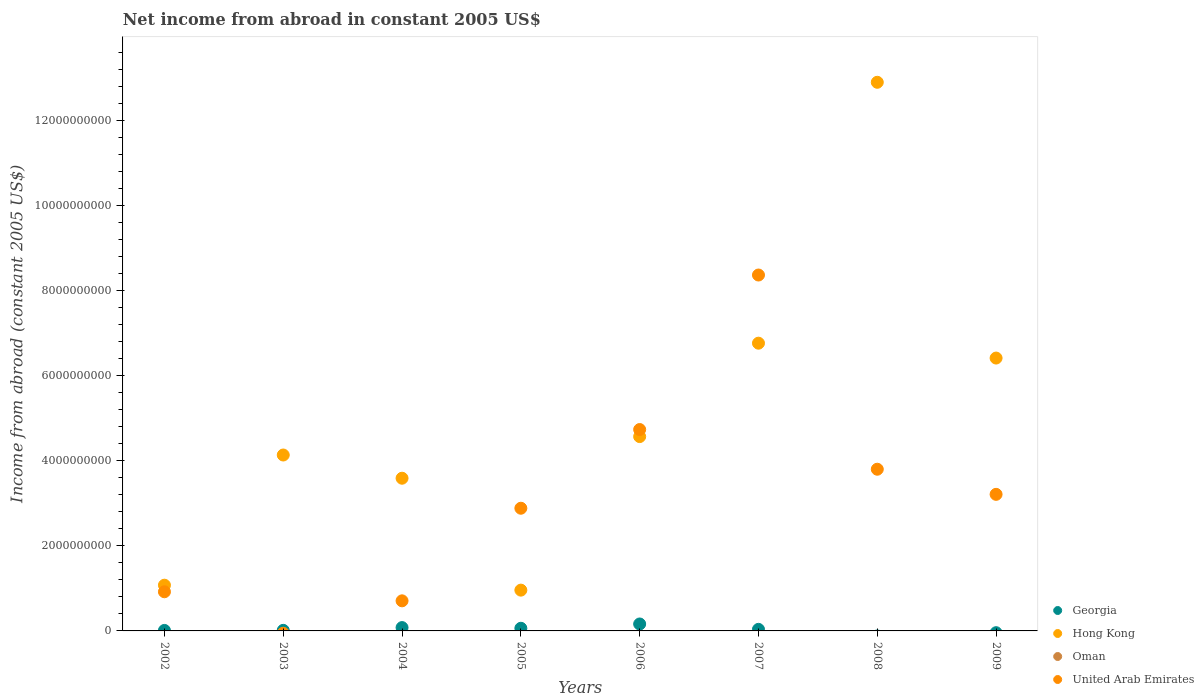Is the number of dotlines equal to the number of legend labels?
Provide a short and direct response. No. Across all years, what is the maximum net income from abroad in Hong Kong?
Provide a succinct answer. 1.29e+1. Across all years, what is the minimum net income from abroad in United Arab Emirates?
Keep it short and to the point. 0. What is the total net income from abroad in Hong Kong in the graph?
Your answer should be compact. 4.04e+1. What is the difference between the net income from abroad in United Arab Emirates in 2004 and that in 2009?
Your answer should be compact. -2.51e+09. What is the difference between the net income from abroad in Georgia in 2005 and the net income from abroad in Oman in 2009?
Offer a very short reply. 6.21e+07. What is the average net income from abroad in United Arab Emirates per year?
Offer a very short reply. 3.08e+09. What is the ratio of the net income from abroad in United Arab Emirates in 2008 to that in 2009?
Your answer should be compact. 1.18. What is the difference between the highest and the second highest net income from abroad in United Arab Emirates?
Your answer should be very brief. 3.64e+09. What is the difference between the highest and the lowest net income from abroad in United Arab Emirates?
Your answer should be compact. 8.37e+09. In how many years, is the net income from abroad in Georgia greater than the average net income from abroad in Georgia taken over all years?
Offer a very short reply. 3. Is the sum of the net income from abroad in United Arab Emirates in 2002 and 2007 greater than the maximum net income from abroad in Hong Kong across all years?
Give a very brief answer. No. Is it the case that in every year, the sum of the net income from abroad in United Arab Emirates and net income from abroad in Georgia  is greater than the sum of net income from abroad in Hong Kong and net income from abroad in Oman?
Your answer should be very brief. No. Is the net income from abroad in Oman strictly greater than the net income from abroad in Georgia over the years?
Make the answer very short. No. Is the net income from abroad in United Arab Emirates strictly less than the net income from abroad in Georgia over the years?
Make the answer very short. No. How many years are there in the graph?
Offer a very short reply. 8. What is the difference between two consecutive major ticks on the Y-axis?
Offer a terse response. 2.00e+09. Does the graph contain any zero values?
Provide a short and direct response. Yes. What is the title of the graph?
Your response must be concise. Net income from abroad in constant 2005 US$. Does "Djibouti" appear as one of the legend labels in the graph?
Offer a terse response. No. What is the label or title of the X-axis?
Your response must be concise. Years. What is the label or title of the Y-axis?
Provide a short and direct response. Income from abroad (constant 2005 US$). What is the Income from abroad (constant 2005 US$) of Georgia in 2002?
Provide a succinct answer. 1.16e+07. What is the Income from abroad (constant 2005 US$) in Hong Kong in 2002?
Provide a succinct answer. 1.08e+09. What is the Income from abroad (constant 2005 US$) in United Arab Emirates in 2002?
Give a very brief answer. 9.21e+08. What is the Income from abroad (constant 2005 US$) of Georgia in 2003?
Provide a succinct answer. 1.35e+07. What is the Income from abroad (constant 2005 US$) in Hong Kong in 2003?
Offer a very short reply. 4.14e+09. What is the Income from abroad (constant 2005 US$) in Oman in 2003?
Your response must be concise. 0. What is the Income from abroad (constant 2005 US$) in Georgia in 2004?
Give a very brief answer. 7.85e+07. What is the Income from abroad (constant 2005 US$) in Hong Kong in 2004?
Ensure brevity in your answer.  3.59e+09. What is the Income from abroad (constant 2005 US$) of Oman in 2004?
Keep it short and to the point. 0. What is the Income from abroad (constant 2005 US$) of United Arab Emirates in 2004?
Your response must be concise. 7.08e+08. What is the Income from abroad (constant 2005 US$) in Georgia in 2005?
Offer a terse response. 6.21e+07. What is the Income from abroad (constant 2005 US$) of Hong Kong in 2005?
Ensure brevity in your answer.  9.60e+08. What is the Income from abroad (constant 2005 US$) of United Arab Emirates in 2005?
Keep it short and to the point. 2.89e+09. What is the Income from abroad (constant 2005 US$) of Georgia in 2006?
Give a very brief answer. 1.63e+08. What is the Income from abroad (constant 2005 US$) in Hong Kong in 2006?
Provide a short and direct response. 4.57e+09. What is the Income from abroad (constant 2005 US$) in United Arab Emirates in 2006?
Provide a succinct answer. 4.74e+09. What is the Income from abroad (constant 2005 US$) of Georgia in 2007?
Give a very brief answer. 3.70e+07. What is the Income from abroad (constant 2005 US$) of Hong Kong in 2007?
Your response must be concise. 6.77e+09. What is the Income from abroad (constant 2005 US$) in United Arab Emirates in 2007?
Offer a very short reply. 8.37e+09. What is the Income from abroad (constant 2005 US$) in Hong Kong in 2008?
Give a very brief answer. 1.29e+1. What is the Income from abroad (constant 2005 US$) in Oman in 2008?
Offer a very short reply. 0. What is the Income from abroad (constant 2005 US$) in United Arab Emirates in 2008?
Provide a succinct answer. 3.80e+09. What is the Income from abroad (constant 2005 US$) of Hong Kong in 2009?
Your answer should be very brief. 6.42e+09. What is the Income from abroad (constant 2005 US$) of Oman in 2009?
Make the answer very short. 0. What is the Income from abroad (constant 2005 US$) in United Arab Emirates in 2009?
Offer a terse response. 3.21e+09. Across all years, what is the maximum Income from abroad (constant 2005 US$) of Georgia?
Your answer should be compact. 1.63e+08. Across all years, what is the maximum Income from abroad (constant 2005 US$) of Hong Kong?
Provide a short and direct response. 1.29e+1. Across all years, what is the maximum Income from abroad (constant 2005 US$) of United Arab Emirates?
Make the answer very short. 8.37e+09. Across all years, what is the minimum Income from abroad (constant 2005 US$) of Hong Kong?
Your response must be concise. 9.60e+08. What is the total Income from abroad (constant 2005 US$) of Georgia in the graph?
Ensure brevity in your answer.  3.66e+08. What is the total Income from abroad (constant 2005 US$) of Hong Kong in the graph?
Your answer should be very brief. 4.04e+1. What is the total Income from abroad (constant 2005 US$) in Oman in the graph?
Provide a succinct answer. 0. What is the total Income from abroad (constant 2005 US$) of United Arab Emirates in the graph?
Keep it short and to the point. 2.46e+1. What is the difference between the Income from abroad (constant 2005 US$) in Georgia in 2002 and that in 2003?
Make the answer very short. -1.88e+06. What is the difference between the Income from abroad (constant 2005 US$) in Hong Kong in 2002 and that in 2003?
Give a very brief answer. -3.06e+09. What is the difference between the Income from abroad (constant 2005 US$) in Georgia in 2002 and that in 2004?
Offer a very short reply. -6.69e+07. What is the difference between the Income from abroad (constant 2005 US$) of Hong Kong in 2002 and that in 2004?
Provide a succinct answer. -2.52e+09. What is the difference between the Income from abroad (constant 2005 US$) of United Arab Emirates in 2002 and that in 2004?
Offer a very short reply. 2.13e+08. What is the difference between the Income from abroad (constant 2005 US$) in Georgia in 2002 and that in 2005?
Your answer should be very brief. -5.06e+07. What is the difference between the Income from abroad (constant 2005 US$) of Hong Kong in 2002 and that in 2005?
Keep it short and to the point. 1.16e+08. What is the difference between the Income from abroad (constant 2005 US$) in United Arab Emirates in 2002 and that in 2005?
Offer a very short reply. -1.97e+09. What is the difference between the Income from abroad (constant 2005 US$) in Georgia in 2002 and that in 2006?
Give a very brief answer. -1.52e+08. What is the difference between the Income from abroad (constant 2005 US$) of Hong Kong in 2002 and that in 2006?
Offer a terse response. -3.50e+09. What is the difference between the Income from abroad (constant 2005 US$) of United Arab Emirates in 2002 and that in 2006?
Provide a succinct answer. -3.82e+09. What is the difference between the Income from abroad (constant 2005 US$) of Georgia in 2002 and that in 2007?
Offer a very short reply. -2.54e+07. What is the difference between the Income from abroad (constant 2005 US$) of Hong Kong in 2002 and that in 2007?
Your response must be concise. -5.69e+09. What is the difference between the Income from abroad (constant 2005 US$) in United Arab Emirates in 2002 and that in 2007?
Provide a succinct answer. -7.45e+09. What is the difference between the Income from abroad (constant 2005 US$) of Hong Kong in 2002 and that in 2008?
Your answer should be compact. -1.18e+1. What is the difference between the Income from abroad (constant 2005 US$) in United Arab Emirates in 2002 and that in 2008?
Your answer should be compact. -2.88e+09. What is the difference between the Income from abroad (constant 2005 US$) of Hong Kong in 2002 and that in 2009?
Your response must be concise. -5.34e+09. What is the difference between the Income from abroad (constant 2005 US$) in United Arab Emirates in 2002 and that in 2009?
Your answer should be very brief. -2.29e+09. What is the difference between the Income from abroad (constant 2005 US$) of Georgia in 2003 and that in 2004?
Keep it short and to the point. -6.50e+07. What is the difference between the Income from abroad (constant 2005 US$) of Hong Kong in 2003 and that in 2004?
Keep it short and to the point. 5.46e+08. What is the difference between the Income from abroad (constant 2005 US$) of Georgia in 2003 and that in 2005?
Provide a short and direct response. -4.87e+07. What is the difference between the Income from abroad (constant 2005 US$) of Hong Kong in 2003 and that in 2005?
Provide a succinct answer. 3.18e+09. What is the difference between the Income from abroad (constant 2005 US$) in Georgia in 2003 and that in 2006?
Make the answer very short. -1.50e+08. What is the difference between the Income from abroad (constant 2005 US$) in Hong Kong in 2003 and that in 2006?
Provide a succinct answer. -4.33e+08. What is the difference between the Income from abroad (constant 2005 US$) in Georgia in 2003 and that in 2007?
Provide a short and direct response. -2.35e+07. What is the difference between the Income from abroad (constant 2005 US$) of Hong Kong in 2003 and that in 2007?
Offer a very short reply. -2.63e+09. What is the difference between the Income from abroad (constant 2005 US$) of Hong Kong in 2003 and that in 2008?
Offer a very short reply. -8.77e+09. What is the difference between the Income from abroad (constant 2005 US$) in Hong Kong in 2003 and that in 2009?
Your answer should be very brief. -2.28e+09. What is the difference between the Income from abroad (constant 2005 US$) of Georgia in 2004 and that in 2005?
Your answer should be compact. 1.63e+07. What is the difference between the Income from abroad (constant 2005 US$) in Hong Kong in 2004 and that in 2005?
Offer a very short reply. 2.63e+09. What is the difference between the Income from abroad (constant 2005 US$) of United Arab Emirates in 2004 and that in 2005?
Give a very brief answer. -2.18e+09. What is the difference between the Income from abroad (constant 2005 US$) in Georgia in 2004 and that in 2006?
Your response must be concise. -8.48e+07. What is the difference between the Income from abroad (constant 2005 US$) in Hong Kong in 2004 and that in 2006?
Your answer should be compact. -9.80e+08. What is the difference between the Income from abroad (constant 2005 US$) of United Arab Emirates in 2004 and that in 2006?
Give a very brief answer. -4.03e+09. What is the difference between the Income from abroad (constant 2005 US$) in Georgia in 2004 and that in 2007?
Ensure brevity in your answer.  4.15e+07. What is the difference between the Income from abroad (constant 2005 US$) in Hong Kong in 2004 and that in 2007?
Your answer should be compact. -3.18e+09. What is the difference between the Income from abroad (constant 2005 US$) in United Arab Emirates in 2004 and that in 2007?
Offer a very short reply. -7.67e+09. What is the difference between the Income from abroad (constant 2005 US$) in Hong Kong in 2004 and that in 2008?
Provide a succinct answer. -9.31e+09. What is the difference between the Income from abroad (constant 2005 US$) in United Arab Emirates in 2004 and that in 2008?
Give a very brief answer. -3.10e+09. What is the difference between the Income from abroad (constant 2005 US$) in Hong Kong in 2004 and that in 2009?
Offer a very short reply. -2.83e+09. What is the difference between the Income from abroad (constant 2005 US$) in United Arab Emirates in 2004 and that in 2009?
Ensure brevity in your answer.  -2.51e+09. What is the difference between the Income from abroad (constant 2005 US$) in Georgia in 2005 and that in 2006?
Offer a very short reply. -1.01e+08. What is the difference between the Income from abroad (constant 2005 US$) in Hong Kong in 2005 and that in 2006?
Give a very brief answer. -3.61e+09. What is the difference between the Income from abroad (constant 2005 US$) in United Arab Emirates in 2005 and that in 2006?
Your response must be concise. -1.85e+09. What is the difference between the Income from abroad (constant 2005 US$) in Georgia in 2005 and that in 2007?
Offer a terse response. 2.52e+07. What is the difference between the Income from abroad (constant 2005 US$) of Hong Kong in 2005 and that in 2007?
Offer a very short reply. -5.81e+09. What is the difference between the Income from abroad (constant 2005 US$) in United Arab Emirates in 2005 and that in 2007?
Offer a terse response. -5.49e+09. What is the difference between the Income from abroad (constant 2005 US$) in Hong Kong in 2005 and that in 2008?
Ensure brevity in your answer.  -1.19e+1. What is the difference between the Income from abroad (constant 2005 US$) of United Arab Emirates in 2005 and that in 2008?
Your answer should be very brief. -9.18e+08. What is the difference between the Income from abroad (constant 2005 US$) of Hong Kong in 2005 and that in 2009?
Provide a short and direct response. -5.46e+09. What is the difference between the Income from abroad (constant 2005 US$) in United Arab Emirates in 2005 and that in 2009?
Your answer should be compact. -3.27e+08. What is the difference between the Income from abroad (constant 2005 US$) in Georgia in 2006 and that in 2007?
Keep it short and to the point. 1.26e+08. What is the difference between the Income from abroad (constant 2005 US$) in Hong Kong in 2006 and that in 2007?
Your response must be concise. -2.20e+09. What is the difference between the Income from abroad (constant 2005 US$) in United Arab Emirates in 2006 and that in 2007?
Provide a short and direct response. -3.64e+09. What is the difference between the Income from abroad (constant 2005 US$) of Hong Kong in 2006 and that in 2008?
Make the answer very short. -8.34e+09. What is the difference between the Income from abroad (constant 2005 US$) in United Arab Emirates in 2006 and that in 2008?
Make the answer very short. 9.34e+08. What is the difference between the Income from abroad (constant 2005 US$) in Hong Kong in 2006 and that in 2009?
Give a very brief answer. -1.85e+09. What is the difference between the Income from abroad (constant 2005 US$) of United Arab Emirates in 2006 and that in 2009?
Your response must be concise. 1.52e+09. What is the difference between the Income from abroad (constant 2005 US$) of Hong Kong in 2007 and that in 2008?
Offer a terse response. -6.14e+09. What is the difference between the Income from abroad (constant 2005 US$) of United Arab Emirates in 2007 and that in 2008?
Give a very brief answer. 4.57e+09. What is the difference between the Income from abroad (constant 2005 US$) of Hong Kong in 2007 and that in 2009?
Offer a very short reply. 3.50e+08. What is the difference between the Income from abroad (constant 2005 US$) of United Arab Emirates in 2007 and that in 2009?
Provide a succinct answer. 5.16e+09. What is the difference between the Income from abroad (constant 2005 US$) in Hong Kong in 2008 and that in 2009?
Your answer should be very brief. 6.49e+09. What is the difference between the Income from abroad (constant 2005 US$) of United Arab Emirates in 2008 and that in 2009?
Keep it short and to the point. 5.91e+08. What is the difference between the Income from abroad (constant 2005 US$) in Georgia in 2002 and the Income from abroad (constant 2005 US$) in Hong Kong in 2003?
Your answer should be compact. -4.13e+09. What is the difference between the Income from abroad (constant 2005 US$) of Georgia in 2002 and the Income from abroad (constant 2005 US$) of Hong Kong in 2004?
Provide a short and direct response. -3.58e+09. What is the difference between the Income from abroad (constant 2005 US$) in Georgia in 2002 and the Income from abroad (constant 2005 US$) in United Arab Emirates in 2004?
Your answer should be very brief. -6.96e+08. What is the difference between the Income from abroad (constant 2005 US$) of Hong Kong in 2002 and the Income from abroad (constant 2005 US$) of United Arab Emirates in 2004?
Provide a short and direct response. 3.68e+08. What is the difference between the Income from abroad (constant 2005 US$) in Georgia in 2002 and the Income from abroad (constant 2005 US$) in Hong Kong in 2005?
Make the answer very short. -9.48e+08. What is the difference between the Income from abroad (constant 2005 US$) in Georgia in 2002 and the Income from abroad (constant 2005 US$) in United Arab Emirates in 2005?
Ensure brevity in your answer.  -2.87e+09. What is the difference between the Income from abroad (constant 2005 US$) in Hong Kong in 2002 and the Income from abroad (constant 2005 US$) in United Arab Emirates in 2005?
Make the answer very short. -1.81e+09. What is the difference between the Income from abroad (constant 2005 US$) in Georgia in 2002 and the Income from abroad (constant 2005 US$) in Hong Kong in 2006?
Keep it short and to the point. -4.56e+09. What is the difference between the Income from abroad (constant 2005 US$) of Georgia in 2002 and the Income from abroad (constant 2005 US$) of United Arab Emirates in 2006?
Offer a very short reply. -4.73e+09. What is the difference between the Income from abroad (constant 2005 US$) of Hong Kong in 2002 and the Income from abroad (constant 2005 US$) of United Arab Emirates in 2006?
Ensure brevity in your answer.  -3.66e+09. What is the difference between the Income from abroad (constant 2005 US$) in Georgia in 2002 and the Income from abroad (constant 2005 US$) in Hong Kong in 2007?
Provide a short and direct response. -6.76e+09. What is the difference between the Income from abroad (constant 2005 US$) of Georgia in 2002 and the Income from abroad (constant 2005 US$) of United Arab Emirates in 2007?
Keep it short and to the point. -8.36e+09. What is the difference between the Income from abroad (constant 2005 US$) of Hong Kong in 2002 and the Income from abroad (constant 2005 US$) of United Arab Emirates in 2007?
Give a very brief answer. -7.30e+09. What is the difference between the Income from abroad (constant 2005 US$) of Georgia in 2002 and the Income from abroad (constant 2005 US$) of Hong Kong in 2008?
Offer a terse response. -1.29e+1. What is the difference between the Income from abroad (constant 2005 US$) in Georgia in 2002 and the Income from abroad (constant 2005 US$) in United Arab Emirates in 2008?
Your answer should be very brief. -3.79e+09. What is the difference between the Income from abroad (constant 2005 US$) of Hong Kong in 2002 and the Income from abroad (constant 2005 US$) of United Arab Emirates in 2008?
Your answer should be very brief. -2.73e+09. What is the difference between the Income from abroad (constant 2005 US$) of Georgia in 2002 and the Income from abroad (constant 2005 US$) of Hong Kong in 2009?
Ensure brevity in your answer.  -6.41e+09. What is the difference between the Income from abroad (constant 2005 US$) in Georgia in 2002 and the Income from abroad (constant 2005 US$) in United Arab Emirates in 2009?
Make the answer very short. -3.20e+09. What is the difference between the Income from abroad (constant 2005 US$) of Hong Kong in 2002 and the Income from abroad (constant 2005 US$) of United Arab Emirates in 2009?
Your answer should be compact. -2.14e+09. What is the difference between the Income from abroad (constant 2005 US$) in Georgia in 2003 and the Income from abroad (constant 2005 US$) in Hong Kong in 2004?
Provide a short and direct response. -3.58e+09. What is the difference between the Income from abroad (constant 2005 US$) of Georgia in 2003 and the Income from abroad (constant 2005 US$) of United Arab Emirates in 2004?
Provide a short and direct response. -6.94e+08. What is the difference between the Income from abroad (constant 2005 US$) in Hong Kong in 2003 and the Income from abroad (constant 2005 US$) in United Arab Emirates in 2004?
Ensure brevity in your answer.  3.43e+09. What is the difference between the Income from abroad (constant 2005 US$) in Georgia in 2003 and the Income from abroad (constant 2005 US$) in Hong Kong in 2005?
Your response must be concise. -9.46e+08. What is the difference between the Income from abroad (constant 2005 US$) in Georgia in 2003 and the Income from abroad (constant 2005 US$) in United Arab Emirates in 2005?
Your answer should be compact. -2.87e+09. What is the difference between the Income from abroad (constant 2005 US$) in Hong Kong in 2003 and the Income from abroad (constant 2005 US$) in United Arab Emirates in 2005?
Provide a succinct answer. 1.25e+09. What is the difference between the Income from abroad (constant 2005 US$) of Georgia in 2003 and the Income from abroad (constant 2005 US$) of Hong Kong in 2006?
Offer a very short reply. -4.56e+09. What is the difference between the Income from abroad (constant 2005 US$) of Georgia in 2003 and the Income from abroad (constant 2005 US$) of United Arab Emirates in 2006?
Ensure brevity in your answer.  -4.72e+09. What is the difference between the Income from abroad (constant 2005 US$) in Hong Kong in 2003 and the Income from abroad (constant 2005 US$) in United Arab Emirates in 2006?
Provide a short and direct response. -5.99e+08. What is the difference between the Income from abroad (constant 2005 US$) in Georgia in 2003 and the Income from abroad (constant 2005 US$) in Hong Kong in 2007?
Your answer should be very brief. -6.76e+09. What is the difference between the Income from abroad (constant 2005 US$) in Georgia in 2003 and the Income from abroad (constant 2005 US$) in United Arab Emirates in 2007?
Keep it short and to the point. -8.36e+09. What is the difference between the Income from abroad (constant 2005 US$) in Hong Kong in 2003 and the Income from abroad (constant 2005 US$) in United Arab Emirates in 2007?
Your response must be concise. -4.23e+09. What is the difference between the Income from abroad (constant 2005 US$) in Georgia in 2003 and the Income from abroad (constant 2005 US$) in Hong Kong in 2008?
Ensure brevity in your answer.  -1.29e+1. What is the difference between the Income from abroad (constant 2005 US$) of Georgia in 2003 and the Income from abroad (constant 2005 US$) of United Arab Emirates in 2008?
Give a very brief answer. -3.79e+09. What is the difference between the Income from abroad (constant 2005 US$) of Hong Kong in 2003 and the Income from abroad (constant 2005 US$) of United Arab Emirates in 2008?
Offer a terse response. 3.35e+08. What is the difference between the Income from abroad (constant 2005 US$) of Georgia in 2003 and the Income from abroad (constant 2005 US$) of Hong Kong in 2009?
Your answer should be very brief. -6.41e+09. What is the difference between the Income from abroad (constant 2005 US$) in Georgia in 2003 and the Income from abroad (constant 2005 US$) in United Arab Emirates in 2009?
Provide a succinct answer. -3.20e+09. What is the difference between the Income from abroad (constant 2005 US$) of Hong Kong in 2003 and the Income from abroad (constant 2005 US$) of United Arab Emirates in 2009?
Ensure brevity in your answer.  9.25e+08. What is the difference between the Income from abroad (constant 2005 US$) of Georgia in 2004 and the Income from abroad (constant 2005 US$) of Hong Kong in 2005?
Your response must be concise. -8.81e+08. What is the difference between the Income from abroad (constant 2005 US$) of Georgia in 2004 and the Income from abroad (constant 2005 US$) of United Arab Emirates in 2005?
Keep it short and to the point. -2.81e+09. What is the difference between the Income from abroad (constant 2005 US$) in Hong Kong in 2004 and the Income from abroad (constant 2005 US$) in United Arab Emirates in 2005?
Provide a succinct answer. 7.06e+08. What is the difference between the Income from abroad (constant 2005 US$) of Georgia in 2004 and the Income from abroad (constant 2005 US$) of Hong Kong in 2006?
Provide a short and direct response. -4.49e+09. What is the difference between the Income from abroad (constant 2005 US$) in Georgia in 2004 and the Income from abroad (constant 2005 US$) in United Arab Emirates in 2006?
Offer a terse response. -4.66e+09. What is the difference between the Income from abroad (constant 2005 US$) of Hong Kong in 2004 and the Income from abroad (constant 2005 US$) of United Arab Emirates in 2006?
Make the answer very short. -1.15e+09. What is the difference between the Income from abroad (constant 2005 US$) in Georgia in 2004 and the Income from abroad (constant 2005 US$) in Hong Kong in 2007?
Make the answer very short. -6.69e+09. What is the difference between the Income from abroad (constant 2005 US$) of Georgia in 2004 and the Income from abroad (constant 2005 US$) of United Arab Emirates in 2007?
Your answer should be compact. -8.29e+09. What is the difference between the Income from abroad (constant 2005 US$) of Hong Kong in 2004 and the Income from abroad (constant 2005 US$) of United Arab Emirates in 2007?
Your answer should be compact. -4.78e+09. What is the difference between the Income from abroad (constant 2005 US$) of Georgia in 2004 and the Income from abroad (constant 2005 US$) of Hong Kong in 2008?
Offer a very short reply. -1.28e+1. What is the difference between the Income from abroad (constant 2005 US$) of Georgia in 2004 and the Income from abroad (constant 2005 US$) of United Arab Emirates in 2008?
Keep it short and to the point. -3.73e+09. What is the difference between the Income from abroad (constant 2005 US$) of Hong Kong in 2004 and the Income from abroad (constant 2005 US$) of United Arab Emirates in 2008?
Offer a very short reply. -2.11e+08. What is the difference between the Income from abroad (constant 2005 US$) of Georgia in 2004 and the Income from abroad (constant 2005 US$) of Hong Kong in 2009?
Ensure brevity in your answer.  -6.34e+09. What is the difference between the Income from abroad (constant 2005 US$) in Georgia in 2004 and the Income from abroad (constant 2005 US$) in United Arab Emirates in 2009?
Make the answer very short. -3.13e+09. What is the difference between the Income from abroad (constant 2005 US$) in Hong Kong in 2004 and the Income from abroad (constant 2005 US$) in United Arab Emirates in 2009?
Offer a very short reply. 3.79e+08. What is the difference between the Income from abroad (constant 2005 US$) in Georgia in 2005 and the Income from abroad (constant 2005 US$) in Hong Kong in 2006?
Your answer should be compact. -4.51e+09. What is the difference between the Income from abroad (constant 2005 US$) in Georgia in 2005 and the Income from abroad (constant 2005 US$) in United Arab Emirates in 2006?
Offer a very short reply. -4.68e+09. What is the difference between the Income from abroad (constant 2005 US$) in Hong Kong in 2005 and the Income from abroad (constant 2005 US$) in United Arab Emirates in 2006?
Give a very brief answer. -3.78e+09. What is the difference between the Income from abroad (constant 2005 US$) of Georgia in 2005 and the Income from abroad (constant 2005 US$) of Hong Kong in 2007?
Offer a very short reply. -6.71e+09. What is the difference between the Income from abroad (constant 2005 US$) of Georgia in 2005 and the Income from abroad (constant 2005 US$) of United Arab Emirates in 2007?
Your response must be concise. -8.31e+09. What is the difference between the Income from abroad (constant 2005 US$) in Hong Kong in 2005 and the Income from abroad (constant 2005 US$) in United Arab Emirates in 2007?
Keep it short and to the point. -7.41e+09. What is the difference between the Income from abroad (constant 2005 US$) in Georgia in 2005 and the Income from abroad (constant 2005 US$) in Hong Kong in 2008?
Your response must be concise. -1.28e+1. What is the difference between the Income from abroad (constant 2005 US$) of Georgia in 2005 and the Income from abroad (constant 2005 US$) of United Arab Emirates in 2008?
Your response must be concise. -3.74e+09. What is the difference between the Income from abroad (constant 2005 US$) of Hong Kong in 2005 and the Income from abroad (constant 2005 US$) of United Arab Emirates in 2008?
Make the answer very short. -2.84e+09. What is the difference between the Income from abroad (constant 2005 US$) of Georgia in 2005 and the Income from abroad (constant 2005 US$) of Hong Kong in 2009?
Your answer should be compact. -6.36e+09. What is the difference between the Income from abroad (constant 2005 US$) of Georgia in 2005 and the Income from abroad (constant 2005 US$) of United Arab Emirates in 2009?
Make the answer very short. -3.15e+09. What is the difference between the Income from abroad (constant 2005 US$) of Hong Kong in 2005 and the Income from abroad (constant 2005 US$) of United Arab Emirates in 2009?
Keep it short and to the point. -2.25e+09. What is the difference between the Income from abroad (constant 2005 US$) in Georgia in 2006 and the Income from abroad (constant 2005 US$) in Hong Kong in 2007?
Provide a succinct answer. -6.61e+09. What is the difference between the Income from abroad (constant 2005 US$) in Georgia in 2006 and the Income from abroad (constant 2005 US$) in United Arab Emirates in 2007?
Keep it short and to the point. -8.21e+09. What is the difference between the Income from abroad (constant 2005 US$) in Hong Kong in 2006 and the Income from abroad (constant 2005 US$) in United Arab Emirates in 2007?
Your answer should be very brief. -3.80e+09. What is the difference between the Income from abroad (constant 2005 US$) of Georgia in 2006 and the Income from abroad (constant 2005 US$) of Hong Kong in 2008?
Your response must be concise. -1.27e+1. What is the difference between the Income from abroad (constant 2005 US$) in Georgia in 2006 and the Income from abroad (constant 2005 US$) in United Arab Emirates in 2008?
Provide a short and direct response. -3.64e+09. What is the difference between the Income from abroad (constant 2005 US$) in Hong Kong in 2006 and the Income from abroad (constant 2005 US$) in United Arab Emirates in 2008?
Provide a short and direct response. 7.68e+08. What is the difference between the Income from abroad (constant 2005 US$) in Georgia in 2006 and the Income from abroad (constant 2005 US$) in Hong Kong in 2009?
Your answer should be very brief. -6.26e+09. What is the difference between the Income from abroad (constant 2005 US$) in Georgia in 2006 and the Income from abroad (constant 2005 US$) in United Arab Emirates in 2009?
Offer a terse response. -3.05e+09. What is the difference between the Income from abroad (constant 2005 US$) of Hong Kong in 2006 and the Income from abroad (constant 2005 US$) of United Arab Emirates in 2009?
Your answer should be very brief. 1.36e+09. What is the difference between the Income from abroad (constant 2005 US$) of Georgia in 2007 and the Income from abroad (constant 2005 US$) of Hong Kong in 2008?
Provide a succinct answer. -1.29e+1. What is the difference between the Income from abroad (constant 2005 US$) of Georgia in 2007 and the Income from abroad (constant 2005 US$) of United Arab Emirates in 2008?
Your response must be concise. -3.77e+09. What is the difference between the Income from abroad (constant 2005 US$) in Hong Kong in 2007 and the Income from abroad (constant 2005 US$) in United Arab Emirates in 2008?
Provide a succinct answer. 2.97e+09. What is the difference between the Income from abroad (constant 2005 US$) in Georgia in 2007 and the Income from abroad (constant 2005 US$) in Hong Kong in 2009?
Give a very brief answer. -6.38e+09. What is the difference between the Income from abroad (constant 2005 US$) in Georgia in 2007 and the Income from abroad (constant 2005 US$) in United Arab Emirates in 2009?
Your answer should be very brief. -3.18e+09. What is the difference between the Income from abroad (constant 2005 US$) in Hong Kong in 2007 and the Income from abroad (constant 2005 US$) in United Arab Emirates in 2009?
Your answer should be compact. 3.56e+09. What is the difference between the Income from abroad (constant 2005 US$) in Hong Kong in 2008 and the Income from abroad (constant 2005 US$) in United Arab Emirates in 2009?
Offer a terse response. 9.69e+09. What is the average Income from abroad (constant 2005 US$) in Georgia per year?
Your response must be concise. 4.57e+07. What is the average Income from abroad (constant 2005 US$) in Hong Kong per year?
Make the answer very short. 5.05e+09. What is the average Income from abroad (constant 2005 US$) in United Arab Emirates per year?
Provide a succinct answer. 3.08e+09. In the year 2002, what is the difference between the Income from abroad (constant 2005 US$) of Georgia and Income from abroad (constant 2005 US$) of Hong Kong?
Give a very brief answer. -1.06e+09. In the year 2002, what is the difference between the Income from abroad (constant 2005 US$) of Georgia and Income from abroad (constant 2005 US$) of United Arab Emirates?
Provide a short and direct response. -9.10e+08. In the year 2002, what is the difference between the Income from abroad (constant 2005 US$) of Hong Kong and Income from abroad (constant 2005 US$) of United Arab Emirates?
Your answer should be very brief. 1.55e+08. In the year 2003, what is the difference between the Income from abroad (constant 2005 US$) in Georgia and Income from abroad (constant 2005 US$) in Hong Kong?
Your answer should be very brief. -4.13e+09. In the year 2004, what is the difference between the Income from abroad (constant 2005 US$) in Georgia and Income from abroad (constant 2005 US$) in Hong Kong?
Offer a very short reply. -3.51e+09. In the year 2004, what is the difference between the Income from abroad (constant 2005 US$) of Georgia and Income from abroad (constant 2005 US$) of United Arab Emirates?
Your answer should be very brief. -6.29e+08. In the year 2004, what is the difference between the Income from abroad (constant 2005 US$) in Hong Kong and Income from abroad (constant 2005 US$) in United Arab Emirates?
Provide a succinct answer. 2.88e+09. In the year 2005, what is the difference between the Income from abroad (constant 2005 US$) in Georgia and Income from abroad (constant 2005 US$) in Hong Kong?
Your response must be concise. -8.97e+08. In the year 2005, what is the difference between the Income from abroad (constant 2005 US$) in Georgia and Income from abroad (constant 2005 US$) in United Arab Emirates?
Offer a very short reply. -2.82e+09. In the year 2005, what is the difference between the Income from abroad (constant 2005 US$) in Hong Kong and Income from abroad (constant 2005 US$) in United Arab Emirates?
Keep it short and to the point. -1.93e+09. In the year 2006, what is the difference between the Income from abroad (constant 2005 US$) in Georgia and Income from abroad (constant 2005 US$) in Hong Kong?
Offer a terse response. -4.41e+09. In the year 2006, what is the difference between the Income from abroad (constant 2005 US$) of Georgia and Income from abroad (constant 2005 US$) of United Arab Emirates?
Make the answer very short. -4.57e+09. In the year 2006, what is the difference between the Income from abroad (constant 2005 US$) of Hong Kong and Income from abroad (constant 2005 US$) of United Arab Emirates?
Offer a terse response. -1.66e+08. In the year 2007, what is the difference between the Income from abroad (constant 2005 US$) of Georgia and Income from abroad (constant 2005 US$) of Hong Kong?
Make the answer very short. -6.73e+09. In the year 2007, what is the difference between the Income from abroad (constant 2005 US$) in Georgia and Income from abroad (constant 2005 US$) in United Arab Emirates?
Your answer should be compact. -8.34e+09. In the year 2007, what is the difference between the Income from abroad (constant 2005 US$) of Hong Kong and Income from abroad (constant 2005 US$) of United Arab Emirates?
Offer a very short reply. -1.60e+09. In the year 2008, what is the difference between the Income from abroad (constant 2005 US$) in Hong Kong and Income from abroad (constant 2005 US$) in United Arab Emirates?
Provide a succinct answer. 9.10e+09. In the year 2009, what is the difference between the Income from abroad (constant 2005 US$) in Hong Kong and Income from abroad (constant 2005 US$) in United Arab Emirates?
Keep it short and to the point. 3.21e+09. What is the ratio of the Income from abroad (constant 2005 US$) of Georgia in 2002 to that in 2003?
Ensure brevity in your answer.  0.86. What is the ratio of the Income from abroad (constant 2005 US$) in Hong Kong in 2002 to that in 2003?
Ensure brevity in your answer.  0.26. What is the ratio of the Income from abroad (constant 2005 US$) in Georgia in 2002 to that in 2004?
Give a very brief answer. 0.15. What is the ratio of the Income from abroad (constant 2005 US$) in Hong Kong in 2002 to that in 2004?
Give a very brief answer. 0.3. What is the ratio of the Income from abroad (constant 2005 US$) in United Arab Emirates in 2002 to that in 2004?
Offer a terse response. 1.3. What is the ratio of the Income from abroad (constant 2005 US$) of Georgia in 2002 to that in 2005?
Keep it short and to the point. 0.19. What is the ratio of the Income from abroad (constant 2005 US$) of Hong Kong in 2002 to that in 2005?
Keep it short and to the point. 1.12. What is the ratio of the Income from abroad (constant 2005 US$) of United Arab Emirates in 2002 to that in 2005?
Give a very brief answer. 0.32. What is the ratio of the Income from abroad (constant 2005 US$) in Georgia in 2002 to that in 2006?
Provide a succinct answer. 0.07. What is the ratio of the Income from abroad (constant 2005 US$) in Hong Kong in 2002 to that in 2006?
Offer a very short reply. 0.24. What is the ratio of the Income from abroad (constant 2005 US$) in United Arab Emirates in 2002 to that in 2006?
Make the answer very short. 0.19. What is the ratio of the Income from abroad (constant 2005 US$) of Georgia in 2002 to that in 2007?
Make the answer very short. 0.31. What is the ratio of the Income from abroad (constant 2005 US$) in Hong Kong in 2002 to that in 2007?
Your answer should be compact. 0.16. What is the ratio of the Income from abroad (constant 2005 US$) of United Arab Emirates in 2002 to that in 2007?
Your response must be concise. 0.11. What is the ratio of the Income from abroad (constant 2005 US$) of Hong Kong in 2002 to that in 2008?
Keep it short and to the point. 0.08. What is the ratio of the Income from abroad (constant 2005 US$) of United Arab Emirates in 2002 to that in 2008?
Offer a terse response. 0.24. What is the ratio of the Income from abroad (constant 2005 US$) of Hong Kong in 2002 to that in 2009?
Ensure brevity in your answer.  0.17. What is the ratio of the Income from abroad (constant 2005 US$) of United Arab Emirates in 2002 to that in 2009?
Keep it short and to the point. 0.29. What is the ratio of the Income from abroad (constant 2005 US$) in Georgia in 2003 to that in 2004?
Your answer should be compact. 0.17. What is the ratio of the Income from abroad (constant 2005 US$) of Hong Kong in 2003 to that in 2004?
Keep it short and to the point. 1.15. What is the ratio of the Income from abroad (constant 2005 US$) of Georgia in 2003 to that in 2005?
Offer a terse response. 0.22. What is the ratio of the Income from abroad (constant 2005 US$) of Hong Kong in 2003 to that in 2005?
Ensure brevity in your answer.  4.31. What is the ratio of the Income from abroad (constant 2005 US$) in Georgia in 2003 to that in 2006?
Make the answer very short. 0.08. What is the ratio of the Income from abroad (constant 2005 US$) of Hong Kong in 2003 to that in 2006?
Your response must be concise. 0.91. What is the ratio of the Income from abroad (constant 2005 US$) of Georgia in 2003 to that in 2007?
Offer a terse response. 0.36. What is the ratio of the Income from abroad (constant 2005 US$) in Hong Kong in 2003 to that in 2007?
Your response must be concise. 0.61. What is the ratio of the Income from abroad (constant 2005 US$) in Hong Kong in 2003 to that in 2008?
Offer a very short reply. 0.32. What is the ratio of the Income from abroad (constant 2005 US$) in Hong Kong in 2003 to that in 2009?
Provide a succinct answer. 0.64. What is the ratio of the Income from abroad (constant 2005 US$) in Georgia in 2004 to that in 2005?
Your answer should be very brief. 1.26. What is the ratio of the Income from abroad (constant 2005 US$) of Hong Kong in 2004 to that in 2005?
Your answer should be very brief. 3.74. What is the ratio of the Income from abroad (constant 2005 US$) in United Arab Emirates in 2004 to that in 2005?
Make the answer very short. 0.25. What is the ratio of the Income from abroad (constant 2005 US$) in Georgia in 2004 to that in 2006?
Your answer should be compact. 0.48. What is the ratio of the Income from abroad (constant 2005 US$) in Hong Kong in 2004 to that in 2006?
Provide a short and direct response. 0.79. What is the ratio of the Income from abroad (constant 2005 US$) of United Arab Emirates in 2004 to that in 2006?
Offer a very short reply. 0.15. What is the ratio of the Income from abroad (constant 2005 US$) in Georgia in 2004 to that in 2007?
Make the answer very short. 2.12. What is the ratio of the Income from abroad (constant 2005 US$) of Hong Kong in 2004 to that in 2007?
Offer a very short reply. 0.53. What is the ratio of the Income from abroad (constant 2005 US$) in United Arab Emirates in 2004 to that in 2007?
Give a very brief answer. 0.08. What is the ratio of the Income from abroad (constant 2005 US$) of Hong Kong in 2004 to that in 2008?
Your answer should be very brief. 0.28. What is the ratio of the Income from abroad (constant 2005 US$) of United Arab Emirates in 2004 to that in 2008?
Your answer should be compact. 0.19. What is the ratio of the Income from abroad (constant 2005 US$) of Hong Kong in 2004 to that in 2009?
Give a very brief answer. 0.56. What is the ratio of the Income from abroad (constant 2005 US$) of United Arab Emirates in 2004 to that in 2009?
Provide a succinct answer. 0.22. What is the ratio of the Income from abroad (constant 2005 US$) in Georgia in 2005 to that in 2006?
Provide a succinct answer. 0.38. What is the ratio of the Income from abroad (constant 2005 US$) in Hong Kong in 2005 to that in 2006?
Provide a succinct answer. 0.21. What is the ratio of the Income from abroad (constant 2005 US$) of United Arab Emirates in 2005 to that in 2006?
Make the answer very short. 0.61. What is the ratio of the Income from abroad (constant 2005 US$) of Georgia in 2005 to that in 2007?
Provide a short and direct response. 1.68. What is the ratio of the Income from abroad (constant 2005 US$) of Hong Kong in 2005 to that in 2007?
Give a very brief answer. 0.14. What is the ratio of the Income from abroad (constant 2005 US$) of United Arab Emirates in 2005 to that in 2007?
Make the answer very short. 0.34. What is the ratio of the Income from abroad (constant 2005 US$) of Hong Kong in 2005 to that in 2008?
Offer a terse response. 0.07. What is the ratio of the Income from abroad (constant 2005 US$) of United Arab Emirates in 2005 to that in 2008?
Your response must be concise. 0.76. What is the ratio of the Income from abroad (constant 2005 US$) in Hong Kong in 2005 to that in 2009?
Provide a short and direct response. 0.15. What is the ratio of the Income from abroad (constant 2005 US$) in United Arab Emirates in 2005 to that in 2009?
Provide a succinct answer. 0.9. What is the ratio of the Income from abroad (constant 2005 US$) of Georgia in 2006 to that in 2007?
Your answer should be very brief. 4.42. What is the ratio of the Income from abroad (constant 2005 US$) of Hong Kong in 2006 to that in 2007?
Provide a short and direct response. 0.68. What is the ratio of the Income from abroad (constant 2005 US$) of United Arab Emirates in 2006 to that in 2007?
Your response must be concise. 0.57. What is the ratio of the Income from abroad (constant 2005 US$) in Hong Kong in 2006 to that in 2008?
Offer a very short reply. 0.35. What is the ratio of the Income from abroad (constant 2005 US$) of United Arab Emirates in 2006 to that in 2008?
Make the answer very short. 1.25. What is the ratio of the Income from abroad (constant 2005 US$) in Hong Kong in 2006 to that in 2009?
Ensure brevity in your answer.  0.71. What is the ratio of the Income from abroad (constant 2005 US$) of United Arab Emirates in 2006 to that in 2009?
Make the answer very short. 1.47. What is the ratio of the Income from abroad (constant 2005 US$) of Hong Kong in 2007 to that in 2008?
Give a very brief answer. 0.52. What is the ratio of the Income from abroad (constant 2005 US$) in United Arab Emirates in 2007 to that in 2008?
Provide a short and direct response. 2.2. What is the ratio of the Income from abroad (constant 2005 US$) of Hong Kong in 2007 to that in 2009?
Your response must be concise. 1.05. What is the ratio of the Income from abroad (constant 2005 US$) in United Arab Emirates in 2007 to that in 2009?
Give a very brief answer. 2.61. What is the ratio of the Income from abroad (constant 2005 US$) in Hong Kong in 2008 to that in 2009?
Provide a succinct answer. 2.01. What is the ratio of the Income from abroad (constant 2005 US$) of United Arab Emirates in 2008 to that in 2009?
Provide a short and direct response. 1.18. What is the difference between the highest and the second highest Income from abroad (constant 2005 US$) in Georgia?
Your answer should be very brief. 8.48e+07. What is the difference between the highest and the second highest Income from abroad (constant 2005 US$) of Hong Kong?
Ensure brevity in your answer.  6.14e+09. What is the difference between the highest and the second highest Income from abroad (constant 2005 US$) in United Arab Emirates?
Offer a terse response. 3.64e+09. What is the difference between the highest and the lowest Income from abroad (constant 2005 US$) of Georgia?
Your response must be concise. 1.63e+08. What is the difference between the highest and the lowest Income from abroad (constant 2005 US$) of Hong Kong?
Provide a succinct answer. 1.19e+1. What is the difference between the highest and the lowest Income from abroad (constant 2005 US$) of United Arab Emirates?
Ensure brevity in your answer.  8.37e+09. 